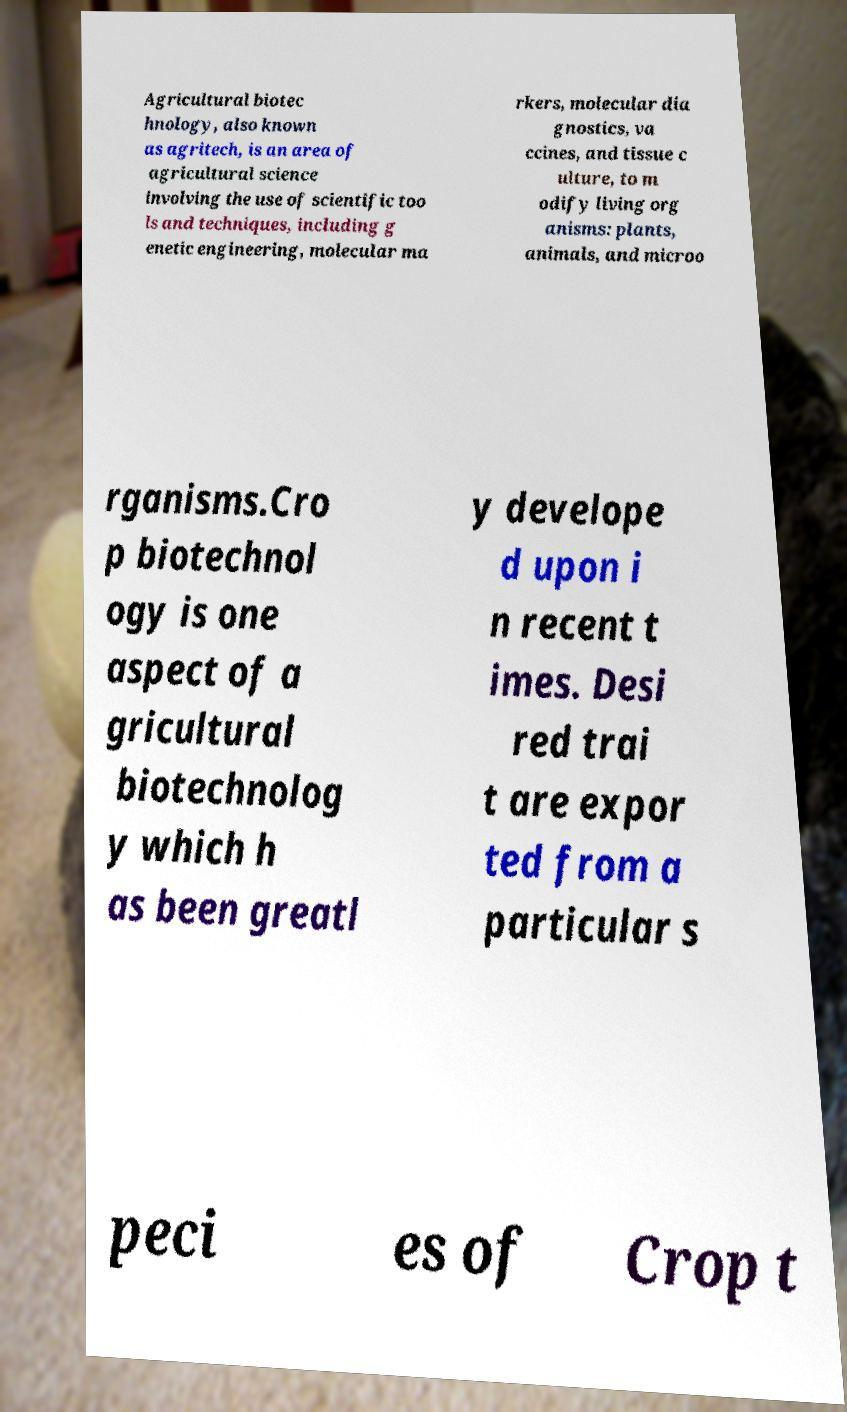Could you extract and type out the text from this image? Agricultural biotec hnology, also known as agritech, is an area of agricultural science involving the use of scientific too ls and techniques, including g enetic engineering, molecular ma rkers, molecular dia gnostics, va ccines, and tissue c ulture, to m odify living org anisms: plants, animals, and microo rganisms.Cro p biotechnol ogy is one aspect of a gricultural biotechnolog y which h as been greatl y develope d upon i n recent t imes. Desi red trai t are expor ted from a particular s peci es of Crop t 